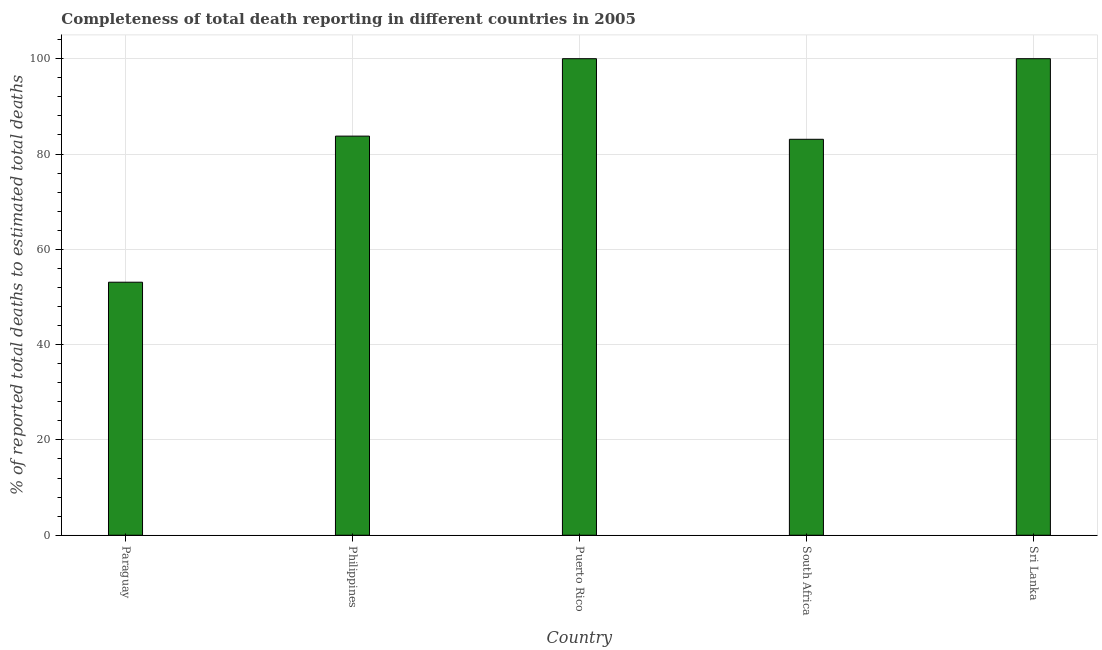Does the graph contain any zero values?
Provide a short and direct response. No. Does the graph contain grids?
Your answer should be compact. Yes. What is the title of the graph?
Ensure brevity in your answer.  Completeness of total death reporting in different countries in 2005. What is the label or title of the X-axis?
Offer a terse response. Country. What is the label or title of the Y-axis?
Your answer should be compact. % of reported total deaths to estimated total deaths. What is the completeness of total death reports in Sri Lanka?
Your answer should be very brief. 100. Across all countries, what is the maximum completeness of total death reports?
Keep it short and to the point. 100. Across all countries, what is the minimum completeness of total death reports?
Offer a terse response. 53.1. In which country was the completeness of total death reports maximum?
Keep it short and to the point. Puerto Rico. In which country was the completeness of total death reports minimum?
Your answer should be compact. Paraguay. What is the sum of the completeness of total death reports?
Provide a short and direct response. 419.94. What is the difference between the completeness of total death reports in Paraguay and Sri Lanka?
Keep it short and to the point. -46.9. What is the average completeness of total death reports per country?
Make the answer very short. 83.99. What is the median completeness of total death reports?
Keep it short and to the point. 83.75. In how many countries, is the completeness of total death reports greater than 52 %?
Give a very brief answer. 5. What is the ratio of the completeness of total death reports in Puerto Rico to that in South Africa?
Offer a terse response. 1.2. Is the completeness of total death reports in Paraguay less than that in Sri Lanka?
Make the answer very short. Yes. Is the difference between the completeness of total death reports in Paraguay and Sri Lanka greater than the difference between any two countries?
Provide a succinct answer. Yes. Is the sum of the completeness of total death reports in Paraguay and Puerto Rico greater than the maximum completeness of total death reports across all countries?
Keep it short and to the point. Yes. What is the difference between the highest and the lowest completeness of total death reports?
Keep it short and to the point. 46.9. In how many countries, is the completeness of total death reports greater than the average completeness of total death reports taken over all countries?
Provide a succinct answer. 2. How many bars are there?
Offer a very short reply. 5. What is the difference between two consecutive major ticks on the Y-axis?
Your response must be concise. 20. What is the % of reported total deaths to estimated total deaths in Paraguay?
Your response must be concise. 53.1. What is the % of reported total deaths to estimated total deaths in Philippines?
Provide a short and direct response. 83.75. What is the % of reported total deaths to estimated total deaths of South Africa?
Keep it short and to the point. 83.09. What is the difference between the % of reported total deaths to estimated total deaths in Paraguay and Philippines?
Offer a very short reply. -30.66. What is the difference between the % of reported total deaths to estimated total deaths in Paraguay and Puerto Rico?
Keep it short and to the point. -46.9. What is the difference between the % of reported total deaths to estimated total deaths in Paraguay and South Africa?
Ensure brevity in your answer.  -29.99. What is the difference between the % of reported total deaths to estimated total deaths in Paraguay and Sri Lanka?
Your answer should be very brief. -46.9. What is the difference between the % of reported total deaths to estimated total deaths in Philippines and Puerto Rico?
Your answer should be very brief. -16.25. What is the difference between the % of reported total deaths to estimated total deaths in Philippines and South Africa?
Your response must be concise. 0.67. What is the difference between the % of reported total deaths to estimated total deaths in Philippines and Sri Lanka?
Offer a terse response. -16.25. What is the difference between the % of reported total deaths to estimated total deaths in Puerto Rico and South Africa?
Offer a terse response. 16.91. What is the difference between the % of reported total deaths to estimated total deaths in Puerto Rico and Sri Lanka?
Keep it short and to the point. 0. What is the difference between the % of reported total deaths to estimated total deaths in South Africa and Sri Lanka?
Your response must be concise. -16.91. What is the ratio of the % of reported total deaths to estimated total deaths in Paraguay to that in Philippines?
Offer a very short reply. 0.63. What is the ratio of the % of reported total deaths to estimated total deaths in Paraguay to that in Puerto Rico?
Ensure brevity in your answer.  0.53. What is the ratio of the % of reported total deaths to estimated total deaths in Paraguay to that in South Africa?
Your response must be concise. 0.64. What is the ratio of the % of reported total deaths to estimated total deaths in Paraguay to that in Sri Lanka?
Provide a short and direct response. 0.53. What is the ratio of the % of reported total deaths to estimated total deaths in Philippines to that in Puerto Rico?
Provide a succinct answer. 0.84. What is the ratio of the % of reported total deaths to estimated total deaths in Philippines to that in Sri Lanka?
Offer a very short reply. 0.84. What is the ratio of the % of reported total deaths to estimated total deaths in Puerto Rico to that in South Africa?
Keep it short and to the point. 1.2. What is the ratio of the % of reported total deaths to estimated total deaths in Puerto Rico to that in Sri Lanka?
Give a very brief answer. 1. What is the ratio of the % of reported total deaths to estimated total deaths in South Africa to that in Sri Lanka?
Provide a short and direct response. 0.83. 